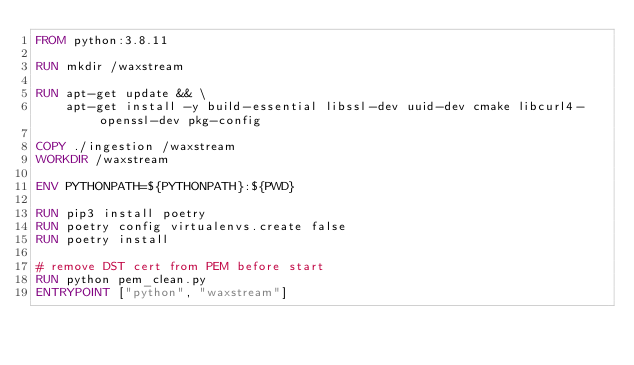Convert code to text. <code><loc_0><loc_0><loc_500><loc_500><_Dockerfile_>FROM python:3.8.11

RUN mkdir /waxstream

RUN apt-get update && \
    apt-get install -y build-essential libssl-dev uuid-dev cmake libcurl4-openssl-dev pkg-config

COPY ./ingestion /waxstream
WORKDIR /waxstream

ENV PYTHONPATH=${PYTHONPATH}:${PWD}

RUN pip3 install poetry
RUN poetry config virtualenvs.create false
RUN poetry install

# remove DST cert from PEM before start
RUN python pem_clean.py
ENTRYPOINT ["python", "waxstream"]
</code> 